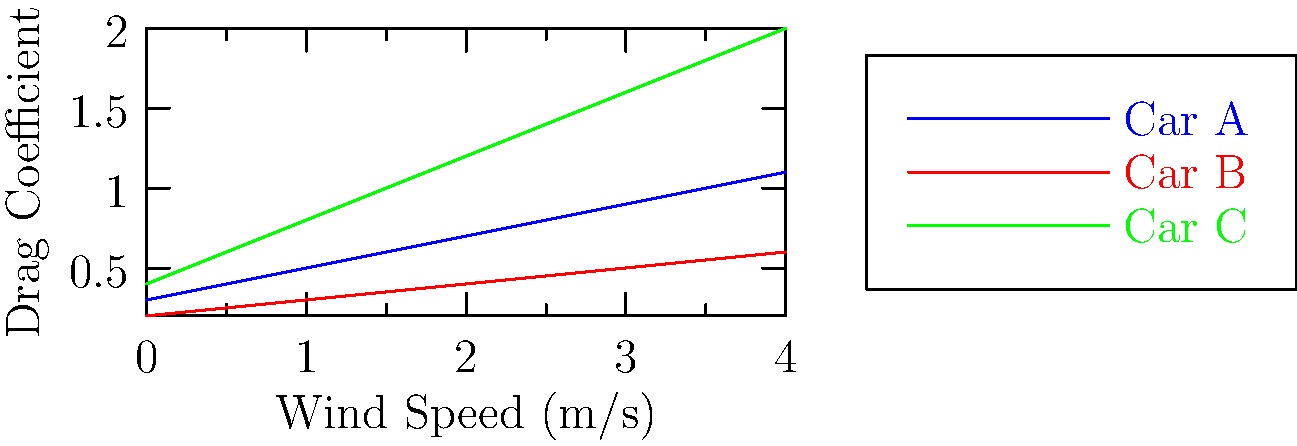In a wind tunnel simulation, three car designs were tested for their aerodynamic properties. The graph shows the drag coefficient of each car model as a function of wind speed. Which car design would likely be the most fuel-efficient at high speeds, and why might this be particularly relevant for a campaign focused on environmental issues? To determine which car design would be the most fuel-efficient at high speeds, we need to analyze the drag coefficients shown in the graph:

1. Understand the relationship: Lower drag coefficient means better aerodynamics and higher fuel efficiency.

2. Analyze the graph:
   - Car A (blue line): Moderate increase in drag coefficient with speed
   - Car B (red line): Lowest drag coefficient across all speeds
   - Car C (green line): Highest drag coefficient, increasing rapidly with speed

3. Compare at high speeds:
   At the highest wind speed (4 m/s), Car B has the lowest drag coefficient (about 0.6), while Car A is around 1.1 and Car C is about 2.0.

4. Conclusion: Car B would likely be the most fuel-efficient at high speeds due to its consistently low drag coefficient.

5. Relevance to an environmental campaign:
   - Fuel efficiency directly relates to reduced carbon emissions
   - Lower fuel consumption means less dependence on fossil fuels
   - Demonstrates commitment to sustainable transportation solutions
   - Aligns with growing public concern about climate change
   - Could be used to promote policies encouraging efficient vehicle design

This topic allows a retired politician to showcase their understanding of both technological advancements and environmental concerns, demonstrating how scientific data can inform policy decisions and campaign strategies.
Answer: Car B; lowest drag coefficient indicates best fuel efficiency, aligning with environmental campaign goals. 